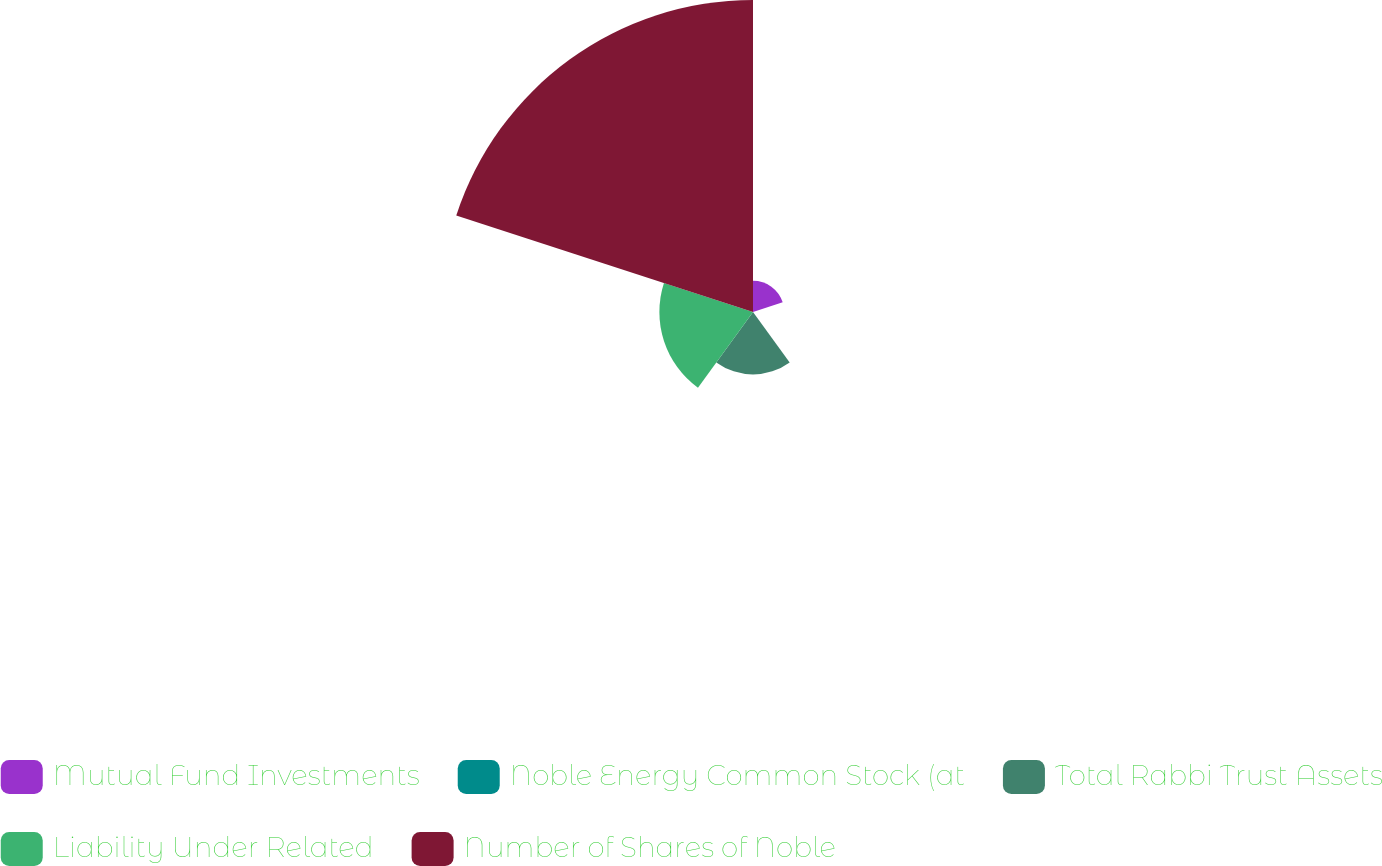Convert chart. <chart><loc_0><loc_0><loc_500><loc_500><pie_chart><fcel>Mutual Fund Investments<fcel>Noble Energy Common Stock (at<fcel>Total Rabbi Trust Assets<fcel>Liability Under Related<fcel>Number of Shares of Noble<nl><fcel>6.25%<fcel>0.01%<fcel>12.5%<fcel>18.75%<fcel>62.49%<nl></chart> 